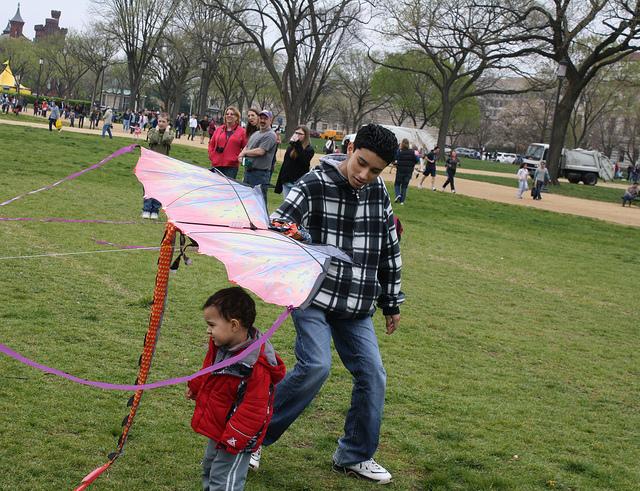Is the child related to the boy?
Answer briefly. Yes. What colors are on the kite?
Quick response, please. Rainbow. Is the man wearing glasses?
Answer briefly. No. Is the child wearing a red coat?
Write a very short answer. Yes. What type of public place is this?
Be succinct. Park. 